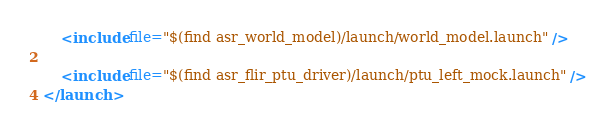<code> <loc_0><loc_0><loc_500><loc_500><_XML_>	<include file="$(find asr_world_model)/launch/world_model.launch" />
	
	<include file="$(find asr_flir_ptu_driver)/launch/ptu_left_mock.launch" />
</launch>
</code> 